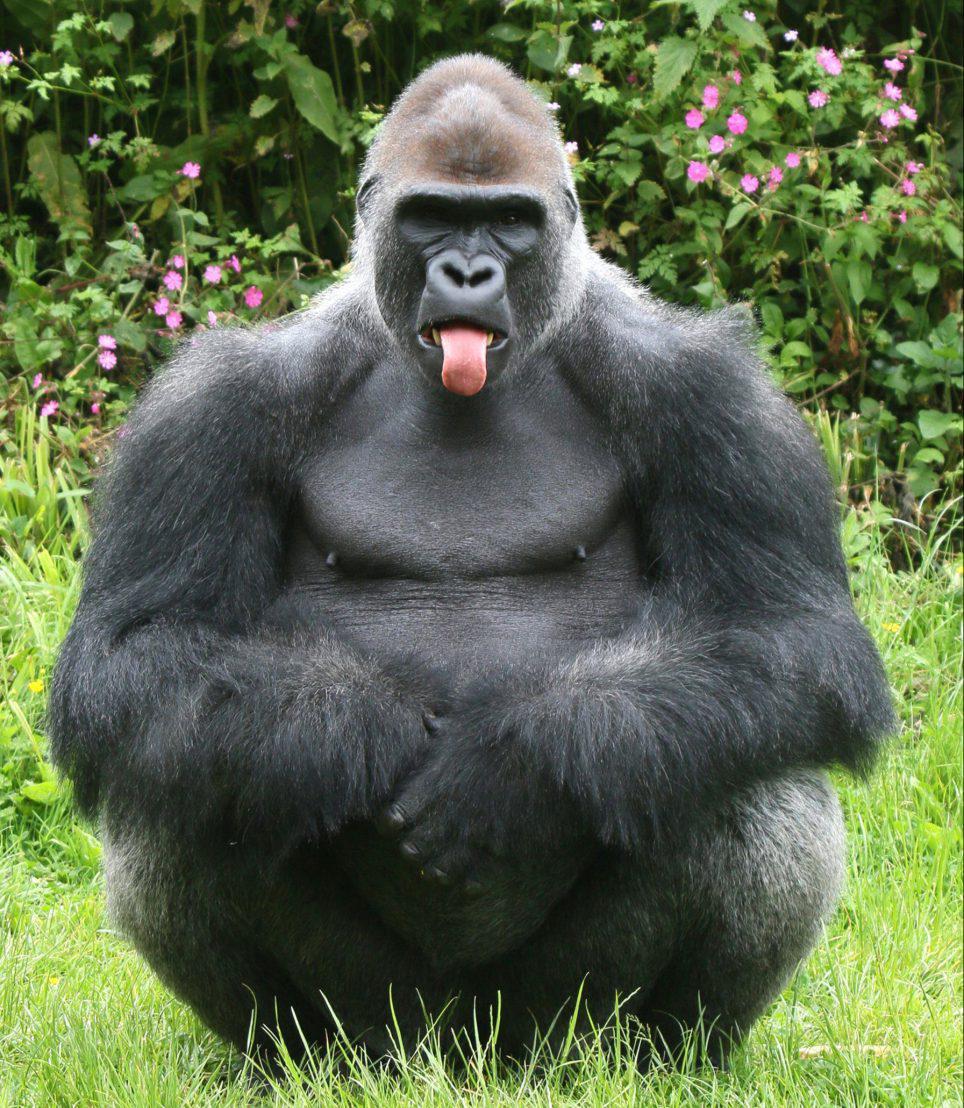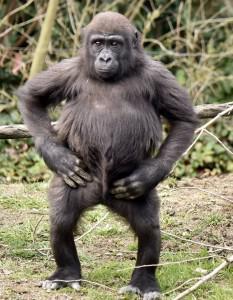The first image is the image on the left, the second image is the image on the right. Assess this claim about the two images: "One image shows exactly three gorillas, including a baby.". Correct or not? Answer yes or no. No. 